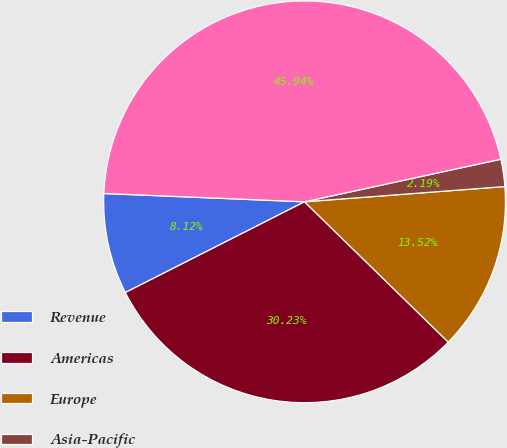<chart> <loc_0><loc_0><loc_500><loc_500><pie_chart><fcel>Revenue<fcel>Americas<fcel>Europe<fcel>Asia-Pacific<fcel>Total revenue<nl><fcel>8.12%<fcel>30.23%<fcel>13.52%<fcel>2.19%<fcel>45.94%<nl></chart> 